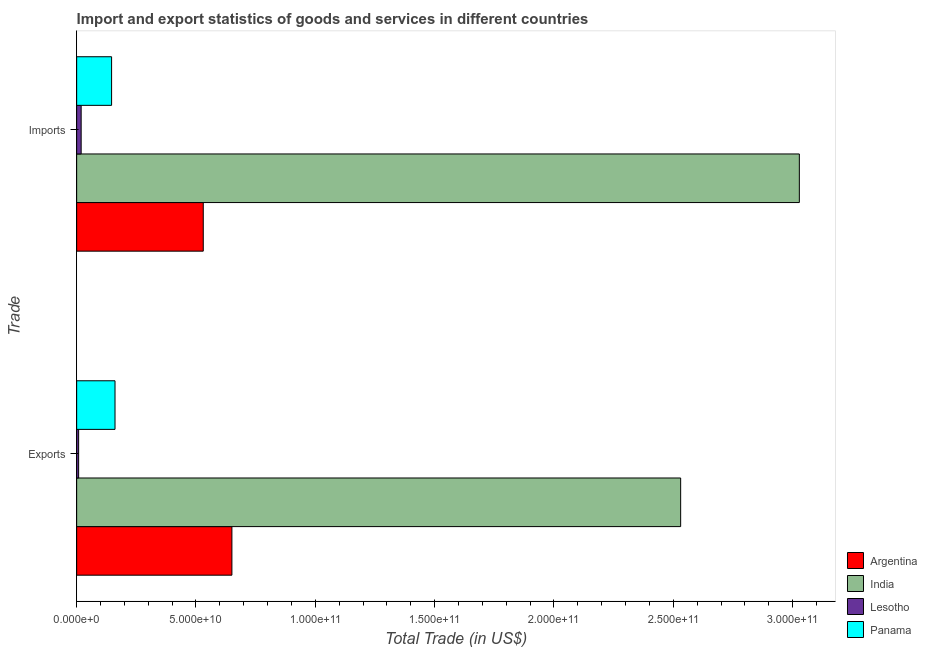How many groups of bars are there?
Your answer should be compact. 2. Are the number of bars per tick equal to the number of legend labels?
Offer a very short reply. Yes. How many bars are there on the 1st tick from the bottom?
Give a very brief answer. 4. What is the label of the 1st group of bars from the top?
Provide a succinct answer. Imports. What is the export of goods and services in Panama?
Ensure brevity in your answer.  1.61e+1. Across all countries, what is the maximum imports of goods and services?
Give a very brief answer. 3.03e+11. Across all countries, what is the minimum export of goods and services?
Keep it short and to the point. 8.32e+08. In which country was the imports of goods and services maximum?
Offer a terse response. India. In which country was the export of goods and services minimum?
Keep it short and to the point. Lesotho. What is the total export of goods and services in the graph?
Make the answer very short. 3.35e+11. What is the difference between the export of goods and services in Lesotho and that in Argentina?
Your response must be concise. -6.42e+1. What is the difference between the export of goods and services in Panama and the imports of goods and services in Argentina?
Keep it short and to the point. -3.70e+1. What is the average export of goods and services per country?
Provide a short and direct response. 8.38e+1. What is the difference between the imports of goods and services and export of goods and services in India?
Ensure brevity in your answer.  4.97e+1. What is the ratio of the imports of goods and services in Lesotho to that in Argentina?
Offer a terse response. 0.04. What does the 4th bar from the top in Exports represents?
Your response must be concise. Argentina. Are all the bars in the graph horizontal?
Provide a short and direct response. Yes. How many countries are there in the graph?
Make the answer very short. 4. What is the difference between two consecutive major ticks on the X-axis?
Keep it short and to the point. 5.00e+1. Are the values on the major ticks of X-axis written in scientific E-notation?
Your response must be concise. Yes. Does the graph contain grids?
Your answer should be compact. No. How many legend labels are there?
Your response must be concise. 4. How are the legend labels stacked?
Your answer should be very brief. Vertical. What is the title of the graph?
Offer a very short reply. Import and export statistics of goods and services in different countries. What is the label or title of the X-axis?
Offer a terse response. Total Trade (in US$). What is the label or title of the Y-axis?
Keep it short and to the point. Trade. What is the Total Trade (in US$) of Argentina in Exports?
Offer a very short reply. 6.50e+1. What is the Total Trade (in US$) of India in Exports?
Provide a succinct answer. 2.53e+11. What is the Total Trade (in US$) of Lesotho in Exports?
Ensure brevity in your answer.  8.32e+08. What is the Total Trade (in US$) in Panama in Exports?
Ensure brevity in your answer.  1.61e+1. What is the Total Trade (in US$) in Argentina in Imports?
Make the answer very short. 5.30e+1. What is the Total Trade (in US$) in India in Imports?
Your answer should be compact. 3.03e+11. What is the Total Trade (in US$) of Lesotho in Imports?
Your answer should be very brief. 1.89e+09. What is the Total Trade (in US$) of Panama in Imports?
Offer a terse response. 1.46e+1. Across all Trade, what is the maximum Total Trade (in US$) of Argentina?
Give a very brief answer. 6.50e+1. Across all Trade, what is the maximum Total Trade (in US$) of India?
Ensure brevity in your answer.  3.03e+11. Across all Trade, what is the maximum Total Trade (in US$) of Lesotho?
Offer a very short reply. 1.89e+09. Across all Trade, what is the maximum Total Trade (in US$) of Panama?
Provide a short and direct response. 1.61e+1. Across all Trade, what is the minimum Total Trade (in US$) in Argentina?
Make the answer very short. 5.30e+1. Across all Trade, what is the minimum Total Trade (in US$) in India?
Make the answer very short. 2.53e+11. Across all Trade, what is the minimum Total Trade (in US$) in Lesotho?
Make the answer very short. 8.32e+08. Across all Trade, what is the minimum Total Trade (in US$) in Panama?
Keep it short and to the point. 1.46e+1. What is the total Total Trade (in US$) in Argentina in the graph?
Provide a succinct answer. 1.18e+11. What is the total Total Trade (in US$) of India in the graph?
Provide a short and direct response. 5.56e+11. What is the total Total Trade (in US$) of Lesotho in the graph?
Offer a terse response. 2.72e+09. What is the total Total Trade (in US$) in Panama in the graph?
Provide a short and direct response. 3.07e+1. What is the difference between the Total Trade (in US$) in Argentina in Exports and that in Imports?
Your answer should be very brief. 1.20e+1. What is the difference between the Total Trade (in US$) in India in Exports and that in Imports?
Provide a short and direct response. -4.97e+1. What is the difference between the Total Trade (in US$) of Lesotho in Exports and that in Imports?
Your answer should be compact. -1.05e+09. What is the difference between the Total Trade (in US$) of Panama in Exports and that in Imports?
Your response must be concise. 1.44e+09. What is the difference between the Total Trade (in US$) in Argentina in Exports and the Total Trade (in US$) in India in Imports?
Provide a short and direct response. -2.38e+11. What is the difference between the Total Trade (in US$) of Argentina in Exports and the Total Trade (in US$) of Lesotho in Imports?
Provide a short and direct response. 6.32e+1. What is the difference between the Total Trade (in US$) in Argentina in Exports and the Total Trade (in US$) in Panama in Imports?
Make the answer very short. 5.04e+1. What is the difference between the Total Trade (in US$) in India in Exports and the Total Trade (in US$) in Lesotho in Imports?
Provide a short and direct response. 2.51e+11. What is the difference between the Total Trade (in US$) in India in Exports and the Total Trade (in US$) in Panama in Imports?
Provide a short and direct response. 2.38e+11. What is the difference between the Total Trade (in US$) in Lesotho in Exports and the Total Trade (in US$) in Panama in Imports?
Provide a succinct answer. -1.38e+1. What is the average Total Trade (in US$) of Argentina per Trade?
Your answer should be compact. 5.90e+1. What is the average Total Trade (in US$) of India per Trade?
Your response must be concise. 2.78e+11. What is the average Total Trade (in US$) of Lesotho per Trade?
Provide a short and direct response. 1.36e+09. What is the average Total Trade (in US$) in Panama per Trade?
Keep it short and to the point. 1.54e+1. What is the difference between the Total Trade (in US$) in Argentina and Total Trade (in US$) in India in Exports?
Your response must be concise. -1.88e+11. What is the difference between the Total Trade (in US$) of Argentina and Total Trade (in US$) of Lesotho in Exports?
Offer a terse response. 6.42e+1. What is the difference between the Total Trade (in US$) in Argentina and Total Trade (in US$) in Panama in Exports?
Your answer should be very brief. 4.90e+1. What is the difference between the Total Trade (in US$) of India and Total Trade (in US$) of Lesotho in Exports?
Provide a short and direct response. 2.52e+11. What is the difference between the Total Trade (in US$) of India and Total Trade (in US$) of Panama in Exports?
Provide a short and direct response. 2.37e+11. What is the difference between the Total Trade (in US$) in Lesotho and Total Trade (in US$) in Panama in Exports?
Your answer should be compact. -1.52e+1. What is the difference between the Total Trade (in US$) of Argentina and Total Trade (in US$) of India in Imports?
Offer a terse response. -2.50e+11. What is the difference between the Total Trade (in US$) of Argentina and Total Trade (in US$) of Lesotho in Imports?
Your answer should be compact. 5.12e+1. What is the difference between the Total Trade (in US$) of Argentina and Total Trade (in US$) of Panama in Imports?
Your answer should be very brief. 3.84e+1. What is the difference between the Total Trade (in US$) in India and Total Trade (in US$) in Lesotho in Imports?
Keep it short and to the point. 3.01e+11. What is the difference between the Total Trade (in US$) of India and Total Trade (in US$) of Panama in Imports?
Keep it short and to the point. 2.88e+11. What is the difference between the Total Trade (in US$) of Lesotho and Total Trade (in US$) of Panama in Imports?
Your response must be concise. -1.28e+1. What is the ratio of the Total Trade (in US$) in Argentina in Exports to that in Imports?
Your response must be concise. 1.23. What is the ratio of the Total Trade (in US$) of India in Exports to that in Imports?
Your answer should be compact. 0.84. What is the ratio of the Total Trade (in US$) in Lesotho in Exports to that in Imports?
Provide a succinct answer. 0.44. What is the ratio of the Total Trade (in US$) of Panama in Exports to that in Imports?
Offer a terse response. 1.1. What is the difference between the highest and the second highest Total Trade (in US$) in Argentina?
Keep it short and to the point. 1.20e+1. What is the difference between the highest and the second highest Total Trade (in US$) of India?
Offer a very short reply. 4.97e+1. What is the difference between the highest and the second highest Total Trade (in US$) of Lesotho?
Your answer should be very brief. 1.05e+09. What is the difference between the highest and the second highest Total Trade (in US$) in Panama?
Give a very brief answer. 1.44e+09. What is the difference between the highest and the lowest Total Trade (in US$) of Argentina?
Make the answer very short. 1.20e+1. What is the difference between the highest and the lowest Total Trade (in US$) in India?
Provide a succinct answer. 4.97e+1. What is the difference between the highest and the lowest Total Trade (in US$) of Lesotho?
Provide a succinct answer. 1.05e+09. What is the difference between the highest and the lowest Total Trade (in US$) of Panama?
Keep it short and to the point. 1.44e+09. 